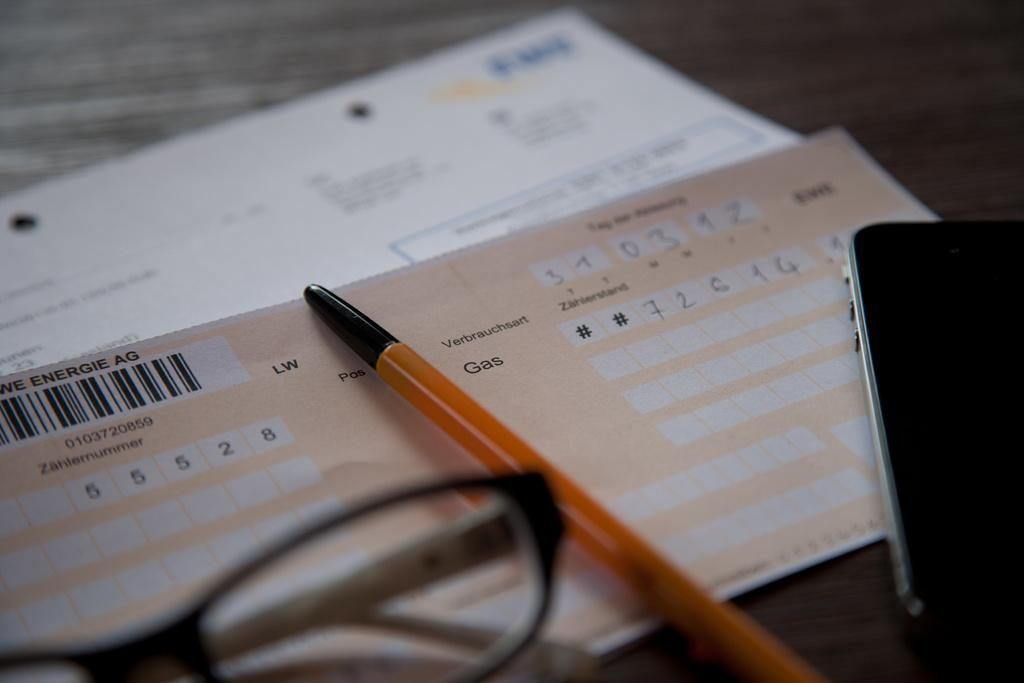<image>
Share a concise interpretation of the image provided. A pen is on top of a form that has the word gas on it. 